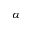<formula> <loc_0><loc_0><loc_500><loc_500>\alpha</formula> 